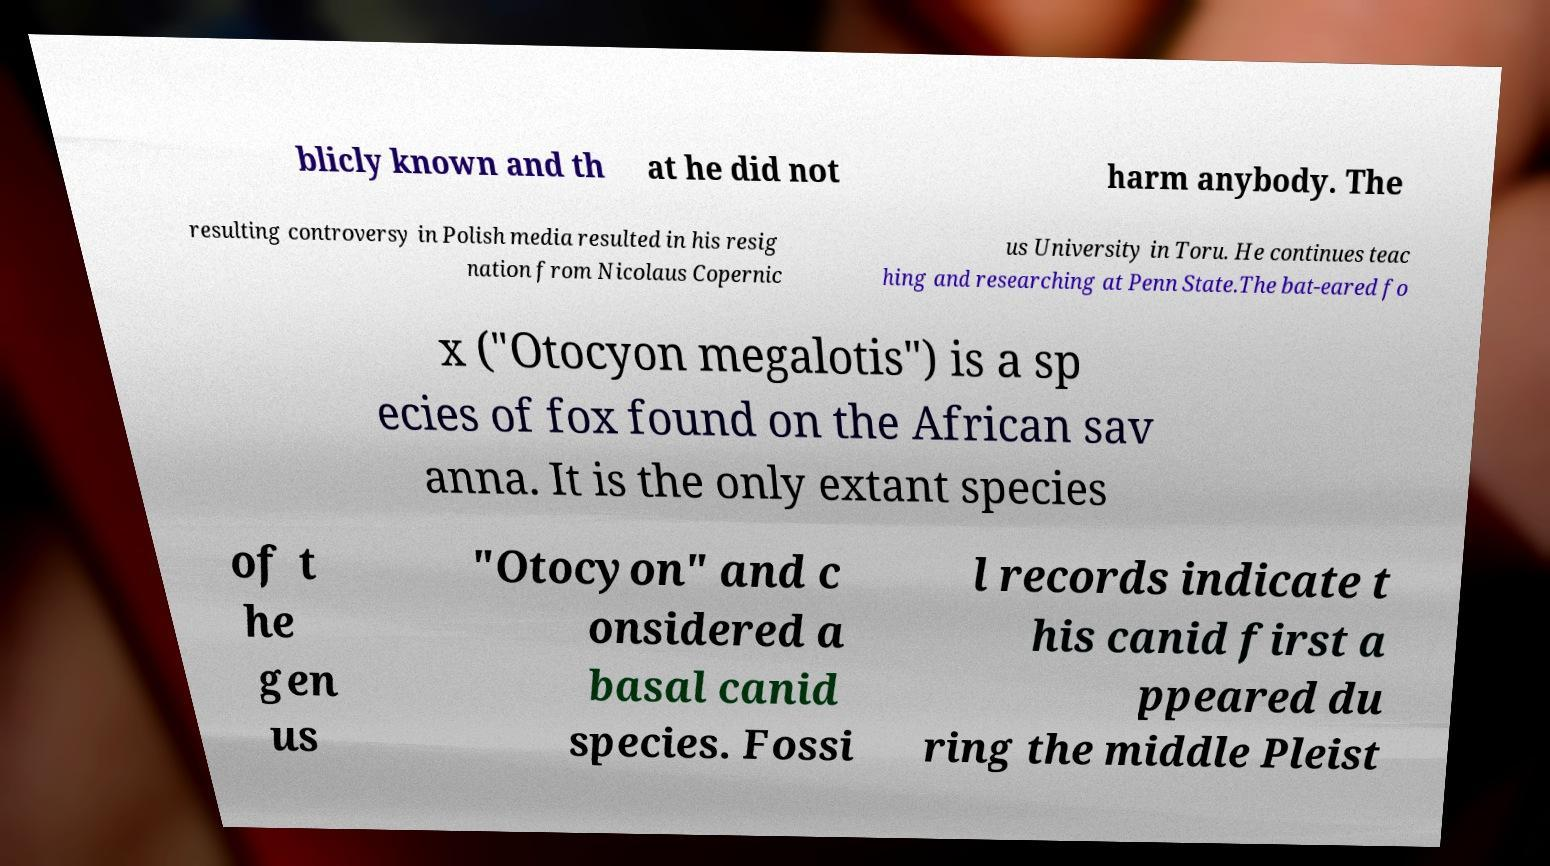I need the written content from this picture converted into text. Can you do that? blicly known and th at he did not harm anybody. The resulting controversy in Polish media resulted in his resig nation from Nicolaus Copernic us University in Toru. He continues teac hing and researching at Penn State.The bat-eared fo x ("Otocyon megalotis") is a sp ecies of fox found on the African sav anna. It is the only extant species of t he gen us "Otocyon" and c onsidered a basal canid species. Fossi l records indicate t his canid first a ppeared du ring the middle Pleist 